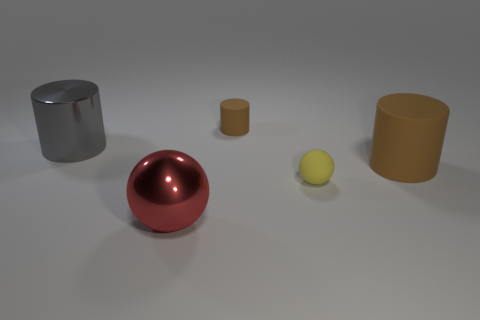There is a rubber object that is the same color as the small rubber cylinder; what size is it?
Provide a succinct answer. Large. Is the size of the gray object the same as the red metallic object?
Your answer should be very brief. Yes. What number of things are either yellow spheres or metallic objects that are behind the big metal ball?
Offer a very short reply. 2. What number of objects are either large things that are behind the big red metallic thing or spheres to the left of the small yellow matte thing?
Offer a very short reply. 3. Are there any balls on the right side of the red metal ball?
Provide a succinct answer. Yes. There is a big thing that is right of the red sphere that is on the left side of the sphere that is to the right of the large metal sphere; what is its color?
Provide a short and direct response. Brown. Is the shape of the large gray metallic thing the same as the tiny brown thing?
Your response must be concise. Yes. There is a large thing that is the same material as the gray cylinder; what is its color?
Provide a succinct answer. Red. How many things are tiny things behind the yellow ball or cyan rubber balls?
Offer a terse response. 1. What is the size of the brown cylinder on the right side of the small matte ball?
Make the answer very short. Large. 